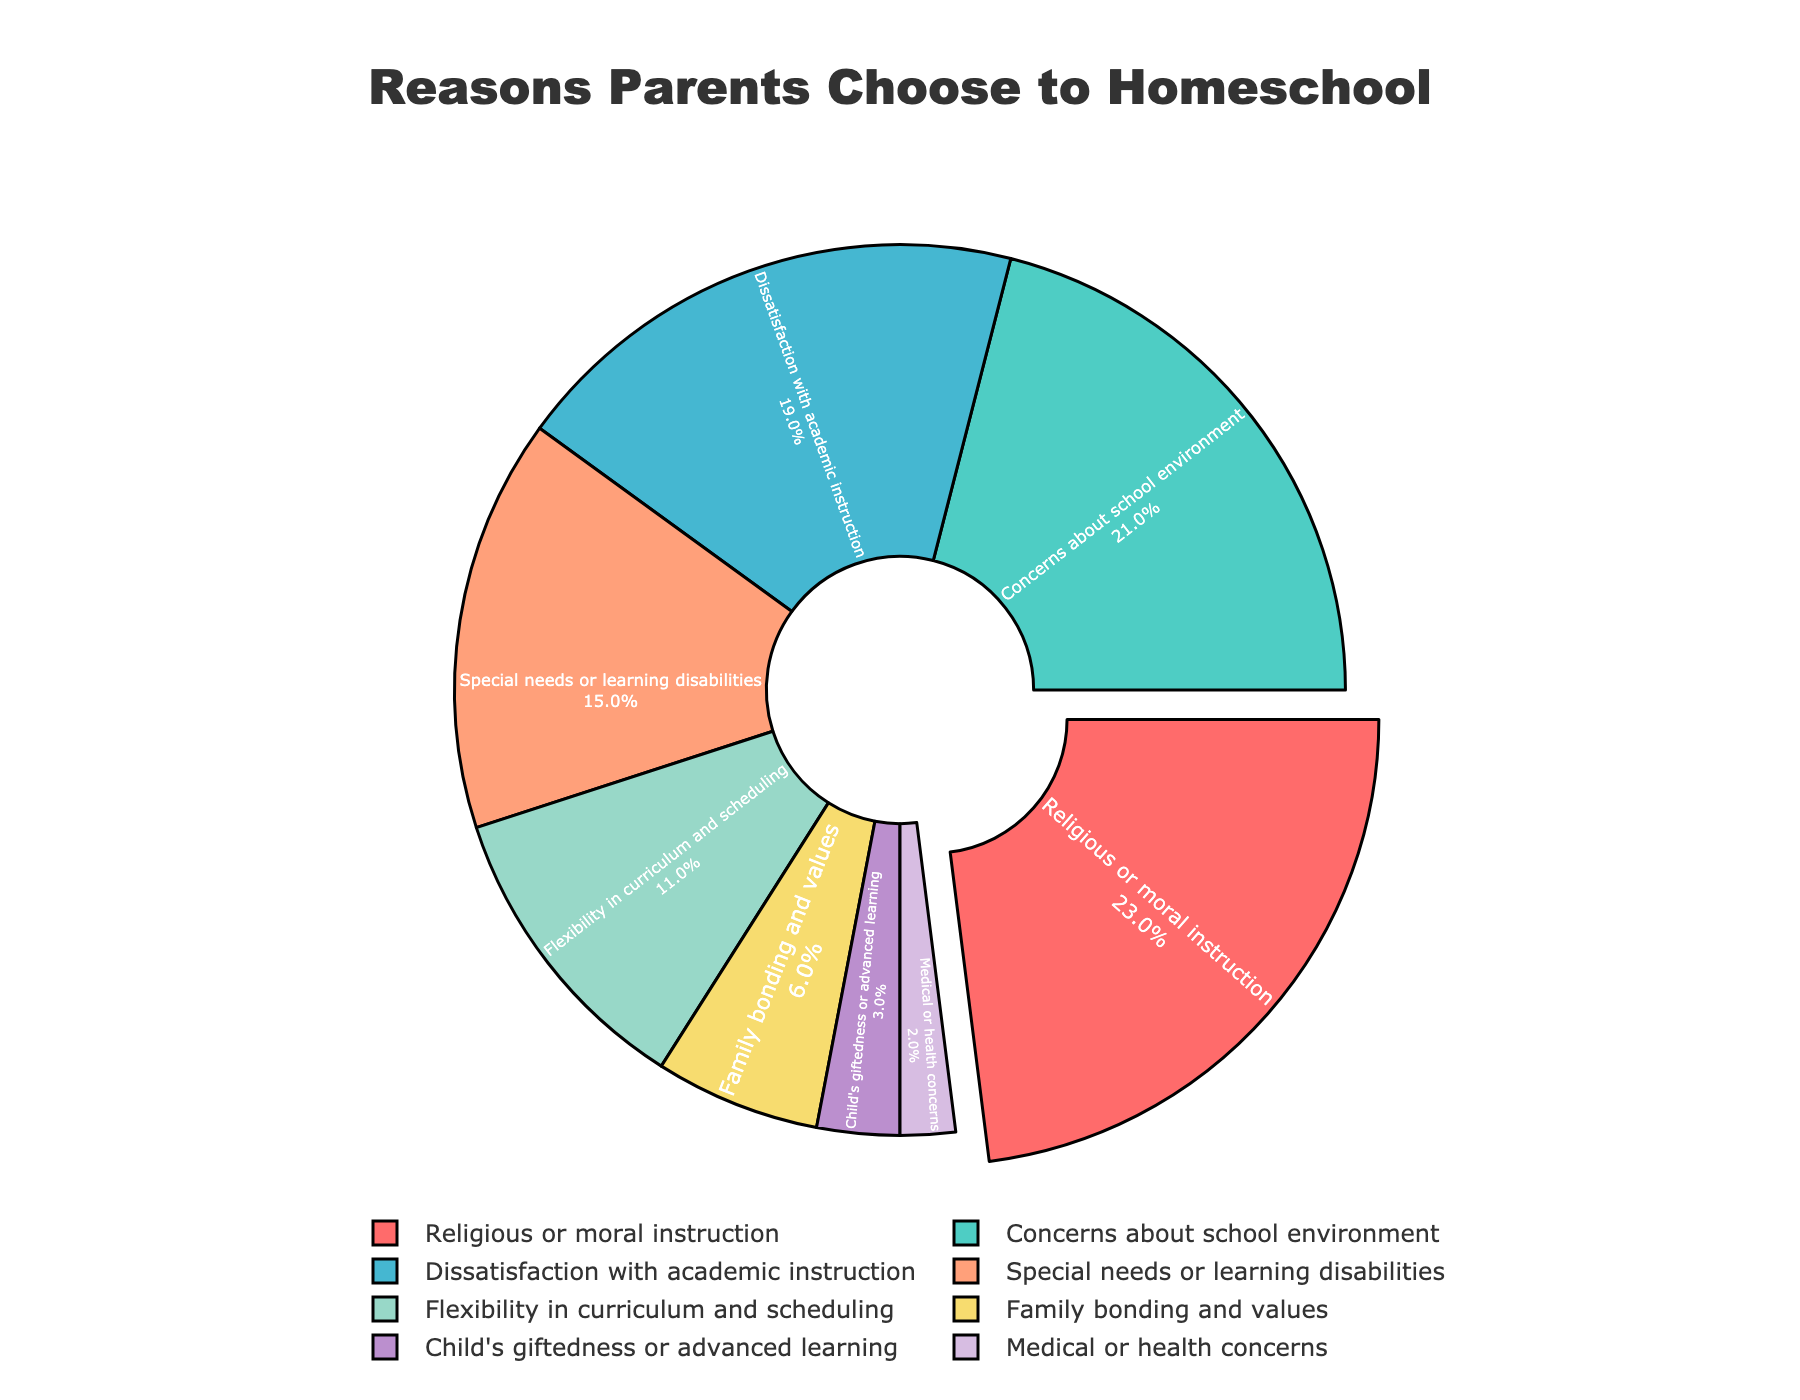Which reason holds the largest percentage for why parents choose to homeschool? The chart shows that "Religious or moral instruction" has the highest percentage among all the reasons.
Answer: Religious or moral instruction What is the combined percentage of "Religious or moral instruction" and "Concerns about school environment"? The percentages for "Religious or moral instruction" and "Concerns about school environment" are 23% and 21%, respectively. Their combined percentage is 23% + 21%.
Answer: 44% Which reason has the smallest percentage, and what is its value? The smallest percentage is represented by "Medical or health concerns," which has a value of 2% as shown in the chart.
Answer: Medical or health concerns, 2% How much greater is the percentage for "Dissatisfaction with academic instruction" than for "Family bonding and values"? "Dissatisfaction with academic instruction" has a percentage of 19%, and "Family bonding and values" has 6%. The difference is calculated by subtracting the smaller percentage from the larger one: 19% - 6%.
Answer: 13% What are the percentages of reasons that fall below 10%? The chart indicates that "Child's giftedness or advanced learning" (3%) and "Medical or health concerns" (2%) are the reasons with percentages below 10%.
Answer: 3%, 2% If you sum the percentages of "Special needs or learning disabilities" and "Flexibility in curriculum and scheduling," what do you get? The percentages for "Special needs or learning disabilities" and "Flexibility in curriculum and scheduling" are 15% and 11%, respectively. Summing these gives 15% + 11%.
Answer: 26% What percentage difference is there between "Concerns about school environment" and "Special needs or learning disabilities"? "Concerns about school environment" accounts for 21%, while "Special needs or learning disabilities" holds 15%. The difference is found by subtracting 15% from 21%.
Answer: 6% Which two reasons have percentages closest to each other, and what are their values? The reasons "Concerns about school environment" and "Dissatisfaction with academic instruction" are closest to each other with percentages of 21% and 19%, respectively. The difference is 2%.
Answer: Concerns about school environment (21%), Dissatisfaction with academic instruction (19%) How many reasons have a percentage of at least 15%? The reasons with percentages of at least 15% are "Religious or moral instruction" (23%), "Concerns about school environment" (21%), "Dissatisfaction with academic instruction" (19%), and "Special needs or learning disabilities" (15%). There are four reasons in total.
Answer: Four reasons 